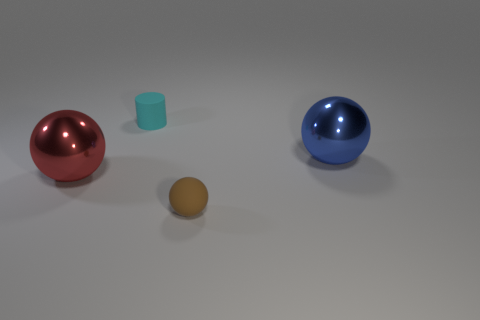Does the big red metallic thing that is behind the tiny brown matte ball have the same shape as the brown rubber object?
Your response must be concise. Yes. What is the size of the matte thing that is to the left of the tiny thing to the right of the cyan rubber object?
Ensure brevity in your answer.  Small. The cylinder that is the same material as the brown ball is what color?
Provide a succinct answer. Cyan. How many cyan rubber objects have the same size as the red sphere?
Make the answer very short. 0. What number of cyan things are large shiny things or tiny cylinders?
Provide a short and direct response. 1. How many objects are small brown objects or objects that are behind the brown matte sphere?
Offer a terse response. 4. What material is the sphere in front of the red object?
Provide a short and direct response. Rubber. What shape is the brown thing that is the same size as the cylinder?
Ensure brevity in your answer.  Sphere. Are there any red things of the same shape as the blue thing?
Provide a succinct answer. Yes. Is the material of the tiny cyan cylinder the same as the small object in front of the big blue metal object?
Provide a succinct answer. Yes. 